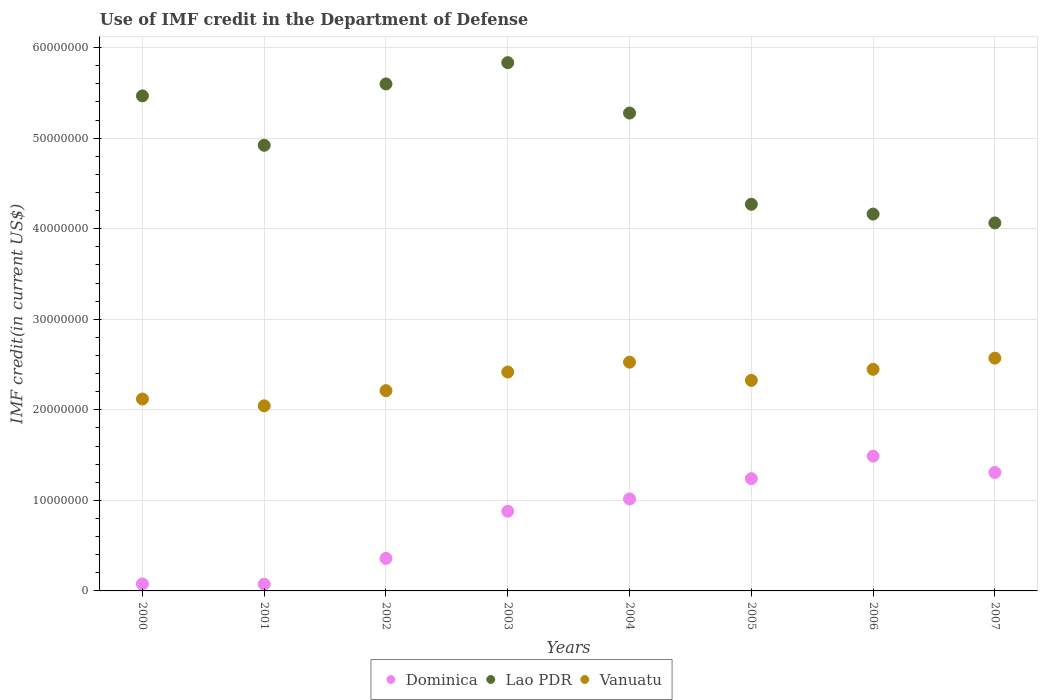What is the IMF credit in the Department of Defense in Lao PDR in 2005?
Ensure brevity in your answer.  4.27e+07. Across all years, what is the maximum IMF credit in the Department of Defense in Dominica?
Offer a very short reply. 1.49e+07. Across all years, what is the minimum IMF credit in the Department of Defense in Lao PDR?
Offer a terse response. 4.06e+07. In which year was the IMF credit in the Department of Defense in Vanuatu maximum?
Your answer should be compact. 2007. In which year was the IMF credit in the Department of Defense in Dominica minimum?
Make the answer very short. 2001. What is the total IMF credit in the Department of Defense in Lao PDR in the graph?
Offer a very short reply. 3.96e+08. What is the difference between the IMF credit in the Department of Defense in Dominica in 2004 and that in 2007?
Offer a very short reply. -2.93e+06. What is the difference between the IMF credit in the Department of Defense in Vanuatu in 2006 and the IMF credit in the Department of Defense in Lao PDR in 2004?
Ensure brevity in your answer.  -2.83e+07. What is the average IMF credit in the Department of Defense in Dominica per year?
Offer a very short reply. 8.05e+06. In the year 2001, what is the difference between the IMF credit in the Department of Defense in Dominica and IMF credit in the Department of Defense in Vanuatu?
Make the answer very short. -1.97e+07. In how many years, is the IMF credit in the Department of Defense in Vanuatu greater than 48000000 US$?
Keep it short and to the point. 0. What is the ratio of the IMF credit in the Department of Defense in Lao PDR in 2005 to that in 2006?
Provide a short and direct response. 1.03. Is the IMF credit in the Department of Defense in Vanuatu in 2003 less than that in 2007?
Provide a short and direct response. Yes. Is the difference between the IMF credit in the Department of Defense in Dominica in 2003 and 2005 greater than the difference between the IMF credit in the Department of Defense in Vanuatu in 2003 and 2005?
Provide a succinct answer. No. What is the difference between the highest and the second highest IMF credit in the Department of Defense in Lao PDR?
Keep it short and to the point. 2.35e+06. What is the difference between the highest and the lowest IMF credit in the Department of Defense in Lao PDR?
Provide a short and direct response. 1.77e+07. In how many years, is the IMF credit in the Department of Defense in Lao PDR greater than the average IMF credit in the Department of Defense in Lao PDR taken over all years?
Provide a short and direct response. 4. Is it the case that in every year, the sum of the IMF credit in the Department of Defense in Dominica and IMF credit in the Department of Defense in Lao PDR  is greater than the IMF credit in the Department of Defense in Vanuatu?
Make the answer very short. Yes. Does the IMF credit in the Department of Defense in Vanuatu monotonically increase over the years?
Offer a terse response. No. Is the IMF credit in the Department of Defense in Dominica strictly greater than the IMF credit in the Department of Defense in Vanuatu over the years?
Ensure brevity in your answer.  No. Is the IMF credit in the Department of Defense in Dominica strictly less than the IMF credit in the Department of Defense in Lao PDR over the years?
Make the answer very short. Yes. How many dotlines are there?
Make the answer very short. 3. How many years are there in the graph?
Your answer should be very brief. 8. What is the difference between two consecutive major ticks on the Y-axis?
Keep it short and to the point. 1.00e+07. Are the values on the major ticks of Y-axis written in scientific E-notation?
Your answer should be very brief. No. Does the graph contain any zero values?
Make the answer very short. No. Does the graph contain grids?
Keep it short and to the point. Yes. How many legend labels are there?
Keep it short and to the point. 3. What is the title of the graph?
Your response must be concise. Use of IMF credit in the Department of Defense. Does "Uganda" appear as one of the legend labels in the graph?
Provide a succinct answer. No. What is the label or title of the X-axis?
Your answer should be very brief. Years. What is the label or title of the Y-axis?
Give a very brief answer. IMF credit(in current US$). What is the IMF credit(in current US$) in Dominica in 2000?
Ensure brevity in your answer.  7.72e+05. What is the IMF credit(in current US$) in Lao PDR in 2000?
Offer a very short reply. 5.47e+07. What is the IMF credit(in current US$) of Vanuatu in 2000?
Your response must be concise. 2.12e+07. What is the IMF credit(in current US$) in Dominica in 2001?
Ensure brevity in your answer.  7.44e+05. What is the IMF credit(in current US$) of Lao PDR in 2001?
Offer a very short reply. 4.92e+07. What is the IMF credit(in current US$) of Vanuatu in 2001?
Give a very brief answer. 2.04e+07. What is the IMF credit(in current US$) in Dominica in 2002?
Make the answer very short. 3.59e+06. What is the IMF credit(in current US$) in Lao PDR in 2002?
Your response must be concise. 5.60e+07. What is the IMF credit(in current US$) of Vanuatu in 2002?
Your response must be concise. 2.21e+07. What is the IMF credit(in current US$) of Dominica in 2003?
Your answer should be compact. 8.80e+06. What is the IMF credit(in current US$) of Lao PDR in 2003?
Make the answer very short. 5.83e+07. What is the IMF credit(in current US$) of Vanuatu in 2003?
Keep it short and to the point. 2.42e+07. What is the IMF credit(in current US$) of Dominica in 2004?
Ensure brevity in your answer.  1.02e+07. What is the IMF credit(in current US$) of Lao PDR in 2004?
Offer a very short reply. 5.28e+07. What is the IMF credit(in current US$) in Vanuatu in 2004?
Give a very brief answer. 2.53e+07. What is the IMF credit(in current US$) in Dominica in 2005?
Your answer should be very brief. 1.24e+07. What is the IMF credit(in current US$) in Lao PDR in 2005?
Offer a very short reply. 4.27e+07. What is the IMF credit(in current US$) of Vanuatu in 2005?
Offer a terse response. 2.32e+07. What is the IMF credit(in current US$) of Dominica in 2006?
Offer a terse response. 1.49e+07. What is the IMF credit(in current US$) in Lao PDR in 2006?
Give a very brief answer. 4.16e+07. What is the IMF credit(in current US$) in Vanuatu in 2006?
Offer a terse response. 2.45e+07. What is the IMF credit(in current US$) in Dominica in 2007?
Your response must be concise. 1.31e+07. What is the IMF credit(in current US$) in Lao PDR in 2007?
Keep it short and to the point. 4.06e+07. What is the IMF credit(in current US$) in Vanuatu in 2007?
Offer a terse response. 2.57e+07. Across all years, what is the maximum IMF credit(in current US$) of Dominica?
Offer a terse response. 1.49e+07. Across all years, what is the maximum IMF credit(in current US$) of Lao PDR?
Your answer should be compact. 5.83e+07. Across all years, what is the maximum IMF credit(in current US$) in Vanuatu?
Your response must be concise. 2.57e+07. Across all years, what is the minimum IMF credit(in current US$) of Dominica?
Provide a short and direct response. 7.44e+05. Across all years, what is the minimum IMF credit(in current US$) in Lao PDR?
Keep it short and to the point. 4.06e+07. Across all years, what is the minimum IMF credit(in current US$) in Vanuatu?
Your answer should be compact. 2.04e+07. What is the total IMF credit(in current US$) in Dominica in the graph?
Your answer should be very brief. 6.44e+07. What is the total IMF credit(in current US$) of Lao PDR in the graph?
Provide a short and direct response. 3.96e+08. What is the total IMF credit(in current US$) of Vanuatu in the graph?
Ensure brevity in your answer.  1.87e+08. What is the difference between the IMF credit(in current US$) of Dominica in 2000 and that in 2001?
Ensure brevity in your answer.  2.80e+04. What is the difference between the IMF credit(in current US$) of Lao PDR in 2000 and that in 2001?
Ensure brevity in your answer.  5.46e+06. What is the difference between the IMF credit(in current US$) of Vanuatu in 2000 and that in 2001?
Offer a terse response. 7.51e+05. What is the difference between the IMF credit(in current US$) in Dominica in 2000 and that in 2002?
Give a very brief answer. -2.82e+06. What is the difference between the IMF credit(in current US$) of Lao PDR in 2000 and that in 2002?
Give a very brief answer. -1.32e+06. What is the difference between the IMF credit(in current US$) of Vanuatu in 2000 and that in 2002?
Your answer should be compact. -9.21e+05. What is the difference between the IMF credit(in current US$) of Dominica in 2000 and that in 2003?
Make the answer very short. -8.03e+06. What is the difference between the IMF credit(in current US$) of Lao PDR in 2000 and that in 2003?
Provide a short and direct response. -3.67e+06. What is the difference between the IMF credit(in current US$) of Vanuatu in 2000 and that in 2003?
Your answer should be very brief. -2.98e+06. What is the difference between the IMF credit(in current US$) in Dominica in 2000 and that in 2004?
Your response must be concise. -9.38e+06. What is the difference between the IMF credit(in current US$) of Lao PDR in 2000 and that in 2004?
Make the answer very short. 1.89e+06. What is the difference between the IMF credit(in current US$) in Vanuatu in 2000 and that in 2004?
Provide a succinct answer. -4.07e+06. What is the difference between the IMF credit(in current US$) in Dominica in 2000 and that in 2005?
Make the answer very short. -1.16e+07. What is the difference between the IMF credit(in current US$) of Lao PDR in 2000 and that in 2005?
Offer a very short reply. 1.20e+07. What is the difference between the IMF credit(in current US$) in Vanuatu in 2000 and that in 2005?
Your answer should be compact. -2.06e+06. What is the difference between the IMF credit(in current US$) of Dominica in 2000 and that in 2006?
Make the answer very short. -1.41e+07. What is the difference between the IMF credit(in current US$) of Lao PDR in 2000 and that in 2006?
Your answer should be compact. 1.31e+07. What is the difference between the IMF credit(in current US$) of Vanuatu in 2000 and that in 2006?
Provide a short and direct response. -3.28e+06. What is the difference between the IMF credit(in current US$) in Dominica in 2000 and that in 2007?
Your answer should be compact. -1.23e+07. What is the difference between the IMF credit(in current US$) in Lao PDR in 2000 and that in 2007?
Make the answer very short. 1.40e+07. What is the difference between the IMF credit(in current US$) in Vanuatu in 2000 and that in 2007?
Your response must be concise. -4.51e+06. What is the difference between the IMF credit(in current US$) of Dominica in 2001 and that in 2002?
Your response must be concise. -2.85e+06. What is the difference between the IMF credit(in current US$) in Lao PDR in 2001 and that in 2002?
Keep it short and to the point. -6.78e+06. What is the difference between the IMF credit(in current US$) in Vanuatu in 2001 and that in 2002?
Your answer should be very brief. -1.67e+06. What is the difference between the IMF credit(in current US$) of Dominica in 2001 and that in 2003?
Keep it short and to the point. -8.06e+06. What is the difference between the IMF credit(in current US$) of Lao PDR in 2001 and that in 2003?
Ensure brevity in your answer.  -9.13e+06. What is the difference between the IMF credit(in current US$) in Vanuatu in 2001 and that in 2003?
Your answer should be compact. -3.73e+06. What is the difference between the IMF credit(in current US$) in Dominica in 2001 and that in 2004?
Your answer should be very brief. -9.41e+06. What is the difference between the IMF credit(in current US$) in Lao PDR in 2001 and that in 2004?
Offer a very short reply. -3.56e+06. What is the difference between the IMF credit(in current US$) of Vanuatu in 2001 and that in 2004?
Your answer should be compact. -4.82e+06. What is the difference between the IMF credit(in current US$) of Dominica in 2001 and that in 2005?
Keep it short and to the point. -1.17e+07. What is the difference between the IMF credit(in current US$) of Lao PDR in 2001 and that in 2005?
Provide a short and direct response. 6.51e+06. What is the difference between the IMF credit(in current US$) in Vanuatu in 2001 and that in 2005?
Offer a terse response. -2.81e+06. What is the difference between the IMF credit(in current US$) of Dominica in 2001 and that in 2006?
Provide a succinct answer. -1.41e+07. What is the difference between the IMF credit(in current US$) of Lao PDR in 2001 and that in 2006?
Ensure brevity in your answer.  7.60e+06. What is the difference between the IMF credit(in current US$) of Vanuatu in 2001 and that in 2006?
Ensure brevity in your answer.  -4.03e+06. What is the difference between the IMF credit(in current US$) of Dominica in 2001 and that in 2007?
Give a very brief answer. -1.23e+07. What is the difference between the IMF credit(in current US$) in Lao PDR in 2001 and that in 2007?
Keep it short and to the point. 8.57e+06. What is the difference between the IMF credit(in current US$) of Vanuatu in 2001 and that in 2007?
Your answer should be very brief. -5.26e+06. What is the difference between the IMF credit(in current US$) in Dominica in 2002 and that in 2003?
Provide a succinct answer. -5.21e+06. What is the difference between the IMF credit(in current US$) in Lao PDR in 2002 and that in 2003?
Provide a short and direct response. -2.35e+06. What is the difference between the IMF credit(in current US$) of Vanuatu in 2002 and that in 2003?
Your answer should be compact. -2.06e+06. What is the difference between the IMF credit(in current US$) of Dominica in 2002 and that in 2004?
Give a very brief answer. -6.56e+06. What is the difference between the IMF credit(in current US$) of Lao PDR in 2002 and that in 2004?
Provide a short and direct response. 3.21e+06. What is the difference between the IMF credit(in current US$) of Vanuatu in 2002 and that in 2004?
Keep it short and to the point. -3.15e+06. What is the difference between the IMF credit(in current US$) of Dominica in 2002 and that in 2005?
Provide a succinct answer. -8.81e+06. What is the difference between the IMF credit(in current US$) of Lao PDR in 2002 and that in 2005?
Provide a short and direct response. 1.33e+07. What is the difference between the IMF credit(in current US$) in Vanuatu in 2002 and that in 2005?
Your answer should be very brief. -1.14e+06. What is the difference between the IMF credit(in current US$) of Dominica in 2002 and that in 2006?
Make the answer very short. -1.13e+07. What is the difference between the IMF credit(in current US$) in Lao PDR in 2002 and that in 2006?
Your answer should be very brief. 1.44e+07. What is the difference between the IMF credit(in current US$) of Vanuatu in 2002 and that in 2006?
Your answer should be compact. -2.36e+06. What is the difference between the IMF credit(in current US$) of Dominica in 2002 and that in 2007?
Offer a very short reply. -9.49e+06. What is the difference between the IMF credit(in current US$) of Lao PDR in 2002 and that in 2007?
Your answer should be very brief. 1.53e+07. What is the difference between the IMF credit(in current US$) of Vanuatu in 2002 and that in 2007?
Keep it short and to the point. -3.59e+06. What is the difference between the IMF credit(in current US$) in Dominica in 2003 and that in 2004?
Ensure brevity in your answer.  -1.35e+06. What is the difference between the IMF credit(in current US$) of Lao PDR in 2003 and that in 2004?
Your answer should be very brief. 5.56e+06. What is the difference between the IMF credit(in current US$) of Vanuatu in 2003 and that in 2004?
Make the answer very short. -1.09e+06. What is the difference between the IMF credit(in current US$) in Dominica in 2003 and that in 2005?
Keep it short and to the point. -3.60e+06. What is the difference between the IMF credit(in current US$) in Lao PDR in 2003 and that in 2005?
Your response must be concise. 1.56e+07. What is the difference between the IMF credit(in current US$) in Vanuatu in 2003 and that in 2005?
Give a very brief answer. 9.22e+05. What is the difference between the IMF credit(in current US$) in Dominica in 2003 and that in 2006?
Provide a succinct answer. -6.08e+06. What is the difference between the IMF credit(in current US$) in Lao PDR in 2003 and that in 2006?
Provide a short and direct response. 1.67e+07. What is the difference between the IMF credit(in current US$) of Vanuatu in 2003 and that in 2006?
Your answer should be very brief. -3.00e+05. What is the difference between the IMF credit(in current US$) in Dominica in 2003 and that in 2007?
Ensure brevity in your answer.  -4.28e+06. What is the difference between the IMF credit(in current US$) in Lao PDR in 2003 and that in 2007?
Keep it short and to the point. 1.77e+07. What is the difference between the IMF credit(in current US$) in Vanuatu in 2003 and that in 2007?
Provide a short and direct response. -1.53e+06. What is the difference between the IMF credit(in current US$) in Dominica in 2004 and that in 2005?
Your answer should be compact. -2.24e+06. What is the difference between the IMF credit(in current US$) in Lao PDR in 2004 and that in 2005?
Provide a succinct answer. 1.01e+07. What is the difference between the IMF credit(in current US$) of Vanuatu in 2004 and that in 2005?
Ensure brevity in your answer.  2.01e+06. What is the difference between the IMF credit(in current US$) of Dominica in 2004 and that in 2006?
Provide a short and direct response. -4.73e+06. What is the difference between the IMF credit(in current US$) of Lao PDR in 2004 and that in 2006?
Ensure brevity in your answer.  1.12e+07. What is the difference between the IMF credit(in current US$) of Vanuatu in 2004 and that in 2006?
Ensure brevity in your answer.  7.90e+05. What is the difference between the IMF credit(in current US$) in Dominica in 2004 and that in 2007?
Provide a succinct answer. -2.93e+06. What is the difference between the IMF credit(in current US$) in Lao PDR in 2004 and that in 2007?
Your response must be concise. 1.21e+07. What is the difference between the IMF credit(in current US$) of Vanuatu in 2004 and that in 2007?
Ensure brevity in your answer.  -4.44e+05. What is the difference between the IMF credit(in current US$) in Dominica in 2005 and that in 2006?
Make the answer very short. -2.49e+06. What is the difference between the IMF credit(in current US$) of Lao PDR in 2005 and that in 2006?
Provide a short and direct response. 1.08e+06. What is the difference between the IMF credit(in current US$) of Vanuatu in 2005 and that in 2006?
Ensure brevity in your answer.  -1.22e+06. What is the difference between the IMF credit(in current US$) of Dominica in 2005 and that in 2007?
Your response must be concise. -6.87e+05. What is the difference between the IMF credit(in current US$) of Lao PDR in 2005 and that in 2007?
Provide a short and direct response. 2.06e+06. What is the difference between the IMF credit(in current US$) in Vanuatu in 2005 and that in 2007?
Make the answer very short. -2.46e+06. What is the difference between the IMF credit(in current US$) in Dominica in 2006 and that in 2007?
Offer a terse response. 1.80e+06. What is the difference between the IMF credit(in current US$) of Lao PDR in 2006 and that in 2007?
Provide a short and direct response. 9.76e+05. What is the difference between the IMF credit(in current US$) of Vanuatu in 2006 and that in 2007?
Keep it short and to the point. -1.23e+06. What is the difference between the IMF credit(in current US$) of Dominica in 2000 and the IMF credit(in current US$) of Lao PDR in 2001?
Your answer should be very brief. -4.84e+07. What is the difference between the IMF credit(in current US$) in Dominica in 2000 and the IMF credit(in current US$) in Vanuatu in 2001?
Your response must be concise. -1.97e+07. What is the difference between the IMF credit(in current US$) in Lao PDR in 2000 and the IMF credit(in current US$) in Vanuatu in 2001?
Provide a short and direct response. 3.42e+07. What is the difference between the IMF credit(in current US$) in Dominica in 2000 and the IMF credit(in current US$) in Lao PDR in 2002?
Offer a very short reply. -5.52e+07. What is the difference between the IMF credit(in current US$) in Dominica in 2000 and the IMF credit(in current US$) in Vanuatu in 2002?
Ensure brevity in your answer.  -2.13e+07. What is the difference between the IMF credit(in current US$) in Lao PDR in 2000 and the IMF credit(in current US$) in Vanuatu in 2002?
Keep it short and to the point. 3.26e+07. What is the difference between the IMF credit(in current US$) of Dominica in 2000 and the IMF credit(in current US$) of Lao PDR in 2003?
Offer a very short reply. -5.76e+07. What is the difference between the IMF credit(in current US$) of Dominica in 2000 and the IMF credit(in current US$) of Vanuatu in 2003?
Ensure brevity in your answer.  -2.34e+07. What is the difference between the IMF credit(in current US$) in Lao PDR in 2000 and the IMF credit(in current US$) in Vanuatu in 2003?
Keep it short and to the point. 3.05e+07. What is the difference between the IMF credit(in current US$) of Dominica in 2000 and the IMF credit(in current US$) of Lao PDR in 2004?
Give a very brief answer. -5.20e+07. What is the difference between the IMF credit(in current US$) in Dominica in 2000 and the IMF credit(in current US$) in Vanuatu in 2004?
Your answer should be compact. -2.45e+07. What is the difference between the IMF credit(in current US$) of Lao PDR in 2000 and the IMF credit(in current US$) of Vanuatu in 2004?
Offer a terse response. 2.94e+07. What is the difference between the IMF credit(in current US$) of Dominica in 2000 and the IMF credit(in current US$) of Lao PDR in 2005?
Ensure brevity in your answer.  -4.19e+07. What is the difference between the IMF credit(in current US$) in Dominica in 2000 and the IMF credit(in current US$) in Vanuatu in 2005?
Your answer should be compact. -2.25e+07. What is the difference between the IMF credit(in current US$) of Lao PDR in 2000 and the IMF credit(in current US$) of Vanuatu in 2005?
Provide a short and direct response. 3.14e+07. What is the difference between the IMF credit(in current US$) of Dominica in 2000 and the IMF credit(in current US$) of Lao PDR in 2006?
Your answer should be compact. -4.08e+07. What is the difference between the IMF credit(in current US$) of Dominica in 2000 and the IMF credit(in current US$) of Vanuatu in 2006?
Offer a terse response. -2.37e+07. What is the difference between the IMF credit(in current US$) of Lao PDR in 2000 and the IMF credit(in current US$) of Vanuatu in 2006?
Provide a succinct answer. 3.02e+07. What is the difference between the IMF credit(in current US$) of Dominica in 2000 and the IMF credit(in current US$) of Lao PDR in 2007?
Your response must be concise. -3.99e+07. What is the difference between the IMF credit(in current US$) of Dominica in 2000 and the IMF credit(in current US$) of Vanuatu in 2007?
Provide a succinct answer. -2.49e+07. What is the difference between the IMF credit(in current US$) of Lao PDR in 2000 and the IMF credit(in current US$) of Vanuatu in 2007?
Your answer should be compact. 2.90e+07. What is the difference between the IMF credit(in current US$) of Dominica in 2001 and the IMF credit(in current US$) of Lao PDR in 2002?
Ensure brevity in your answer.  -5.52e+07. What is the difference between the IMF credit(in current US$) in Dominica in 2001 and the IMF credit(in current US$) in Vanuatu in 2002?
Give a very brief answer. -2.14e+07. What is the difference between the IMF credit(in current US$) of Lao PDR in 2001 and the IMF credit(in current US$) of Vanuatu in 2002?
Make the answer very short. 2.71e+07. What is the difference between the IMF credit(in current US$) of Dominica in 2001 and the IMF credit(in current US$) of Lao PDR in 2003?
Your answer should be compact. -5.76e+07. What is the difference between the IMF credit(in current US$) in Dominica in 2001 and the IMF credit(in current US$) in Vanuatu in 2003?
Your answer should be compact. -2.34e+07. What is the difference between the IMF credit(in current US$) in Lao PDR in 2001 and the IMF credit(in current US$) in Vanuatu in 2003?
Offer a terse response. 2.50e+07. What is the difference between the IMF credit(in current US$) of Dominica in 2001 and the IMF credit(in current US$) of Lao PDR in 2004?
Keep it short and to the point. -5.20e+07. What is the difference between the IMF credit(in current US$) of Dominica in 2001 and the IMF credit(in current US$) of Vanuatu in 2004?
Your answer should be compact. -2.45e+07. What is the difference between the IMF credit(in current US$) in Lao PDR in 2001 and the IMF credit(in current US$) in Vanuatu in 2004?
Provide a succinct answer. 2.39e+07. What is the difference between the IMF credit(in current US$) of Dominica in 2001 and the IMF credit(in current US$) of Lao PDR in 2005?
Ensure brevity in your answer.  -4.20e+07. What is the difference between the IMF credit(in current US$) of Dominica in 2001 and the IMF credit(in current US$) of Vanuatu in 2005?
Give a very brief answer. -2.25e+07. What is the difference between the IMF credit(in current US$) in Lao PDR in 2001 and the IMF credit(in current US$) in Vanuatu in 2005?
Give a very brief answer. 2.60e+07. What is the difference between the IMF credit(in current US$) of Dominica in 2001 and the IMF credit(in current US$) of Lao PDR in 2006?
Ensure brevity in your answer.  -4.09e+07. What is the difference between the IMF credit(in current US$) in Dominica in 2001 and the IMF credit(in current US$) in Vanuatu in 2006?
Make the answer very short. -2.37e+07. What is the difference between the IMF credit(in current US$) in Lao PDR in 2001 and the IMF credit(in current US$) in Vanuatu in 2006?
Provide a short and direct response. 2.47e+07. What is the difference between the IMF credit(in current US$) of Dominica in 2001 and the IMF credit(in current US$) of Lao PDR in 2007?
Give a very brief answer. -3.99e+07. What is the difference between the IMF credit(in current US$) in Dominica in 2001 and the IMF credit(in current US$) in Vanuatu in 2007?
Your answer should be compact. -2.50e+07. What is the difference between the IMF credit(in current US$) in Lao PDR in 2001 and the IMF credit(in current US$) in Vanuatu in 2007?
Make the answer very short. 2.35e+07. What is the difference between the IMF credit(in current US$) in Dominica in 2002 and the IMF credit(in current US$) in Lao PDR in 2003?
Offer a very short reply. -5.47e+07. What is the difference between the IMF credit(in current US$) in Dominica in 2002 and the IMF credit(in current US$) in Vanuatu in 2003?
Give a very brief answer. -2.06e+07. What is the difference between the IMF credit(in current US$) in Lao PDR in 2002 and the IMF credit(in current US$) in Vanuatu in 2003?
Give a very brief answer. 3.18e+07. What is the difference between the IMF credit(in current US$) in Dominica in 2002 and the IMF credit(in current US$) in Lao PDR in 2004?
Ensure brevity in your answer.  -4.92e+07. What is the difference between the IMF credit(in current US$) in Dominica in 2002 and the IMF credit(in current US$) in Vanuatu in 2004?
Keep it short and to the point. -2.17e+07. What is the difference between the IMF credit(in current US$) in Lao PDR in 2002 and the IMF credit(in current US$) in Vanuatu in 2004?
Your answer should be compact. 3.07e+07. What is the difference between the IMF credit(in current US$) in Dominica in 2002 and the IMF credit(in current US$) in Lao PDR in 2005?
Make the answer very short. -3.91e+07. What is the difference between the IMF credit(in current US$) of Dominica in 2002 and the IMF credit(in current US$) of Vanuatu in 2005?
Offer a terse response. -1.97e+07. What is the difference between the IMF credit(in current US$) of Lao PDR in 2002 and the IMF credit(in current US$) of Vanuatu in 2005?
Make the answer very short. 3.27e+07. What is the difference between the IMF credit(in current US$) in Dominica in 2002 and the IMF credit(in current US$) in Lao PDR in 2006?
Make the answer very short. -3.80e+07. What is the difference between the IMF credit(in current US$) in Dominica in 2002 and the IMF credit(in current US$) in Vanuatu in 2006?
Offer a very short reply. -2.09e+07. What is the difference between the IMF credit(in current US$) in Lao PDR in 2002 and the IMF credit(in current US$) in Vanuatu in 2006?
Your response must be concise. 3.15e+07. What is the difference between the IMF credit(in current US$) of Dominica in 2002 and the IMF credit(in current US$) of Lao PDR in 2007?
Your answer should be compact. -3.70e+07. What is the difference between the IMF credit(in current US$) in Dominica in 2002 and the IMF credit(in current US$) in Vanuatu in 2007?
Provide a succinct answer. -2.21e+07. What is the difference between the IMF credit(in current US$) in Lao PDR in 2002 and the IMF credit(in current US$) in Vanuatu in 2007?
Provide a succinct answer. 3.03e+07. What is the difference between the IMF credit(in current US$) of Dominica in 2003 and the IMF credit(in current US$) of Lao PDR in 2004?
Your response must be concise. -4.40e+07. What is the difference between the IMF credit(in current US$) in Dominica in 2003 and the IMF credit(in current US$) in Vanuatu in 2004?
Offer a very short reply. -1.65e+07. What is the difference between the IMF credit(in current US$) in Lao PDR in 2003 and the IMF credit(in current US$) in Vanuatu in 2004?
Your response must be concise. 3.31e+07. What is the difference between the IMF credit(in current US$) in Dominica in 2003 and the IMF credit(in current US$) in Lao PDR in 2005?
Give a very brief answer. -3.39e+07. What is the difference between the IMF credit(in current US$) of Dominica in 2003 and the IMF credit(in current US$) of Vanuatu in 2005?
Give a very brief answer. -1.44e+07. What is the difference between the IMF credit(in current US$) in Lao PDR in 2003 and the IMF credit(in current US$) in Vanuatu in 2005?
Ensure brevity in your answer.  3.51e+07. What is the difference between the IMF credit(in current US$) in Dominica in 2003 and the IMF credit(in current US$) in Lao PDR in 2006?
Ensure brevity in your answer.  -3.28e+07. What is the difference between the IMF credit(in current US$) of Dominica in 2003 and the IMF credit(in current US$) of Vanuatu in 2006?
Offer a very short reply. -1.57e+07. What is the difference between the IMF credit(in current US$) in Lao PDR in 2003 and the IMF credit(in current US$) in Vanuatu in 2006?
Make the answer very short. 3.39e+07. What is the difference between the IMF credit(in current US$) in Dominica in 2003 and the IMF credit(in current US$) in Lao PDR in 2007?
Provide a succinct answer. -3.18e+07. What is the difference between the IMF credit(in current US$) in Dominica in 2003 and the IMF credit(in current US$) in Vanuatu in 2007?
Ensure brevity in your answer.  -1.69e+07. What is the difference between the IMF credit(in current US$) in Lao PDR in 2003 and the IMF credit(in current US$) in Vanuatu in 2007?
Provide a short and direct response. 3.26e+07. What is the difference between the IMF credit(in current US$) of Dominica in 2004 and the IMF credit(in current US$) of Lao PDR in 2005?
Offer a terse response. -3.25e+07. What is the difference between the IMF credit(in current US$) of Dominica in 2004 and the IMF credit(in current US$) of Vanuatu in 2005?
Offer a very short reply. -1.31e+07. What is the difference between the IMF credit(in current US$) in Lao PDR in 2004 and the IMF credit(in current US$) in Vanuatu in 2005?
Your response must be concise. 2.95e+07. What is the difference between the IMF credit(in current US$) in Dominica in 2004 and the IMF credit(in current US$) in Lao PDR in 2006?
Offer a very short reply. -3.15e+07. What is the difference between the IMF credit(in current US$) of Dominica in 2004 and the IMF credit(in current US$) of Vanuatu in 2006?
Your answer should be very brief. -1.43e+07. What is the difference between the IMF credit(in current US$) of Lao PDR in 2004 and the IMF credit(in current US$) of Vanuatu in 2006?
Keep it short and to the point. 2.83e+07. What is the difference between the IMF credit(in current US$) of Dominica in 2004 and the IMF credit(in current US$) of Lao PDR in 2007?
Keep it short and to the point. -3.05e+07. What is the difference between the IMF credit(in current US$) in Dominica in 2004 and the IMF credit(in current US$) in Vanuatu in 2007?
Make the answer very short. -1.56e+07. What is the difference between the IMF credit(in current US$) in Lao PDR in 2004 and the IMF credit(in current US$) in Vanuatu in 2007?
Offer a very short reply. 2.71e+07. What is the difference between the IMF credit(in current US$) of Dominica in 2005 and the IMF credit(in current US$) of Lao PDR in 2006?
Keep it short and to the point. -2.92e+07. What is the difference between the IMF credit(in current US$) of Dominica in 2005 and the IMF credit(in current US$) of Vanuatu in 2006?
Ensure brevity in your answer.  -1.21e+07. What is the difference between the IMF credit(in current US$) in Lao PDR in 2005 and the IMF credit(in current US$) in Vanuatu in 2006?
Ensure brevity in your answer.  1.82e+07. What is the difference between the IMF credit(in current US$) of Dominica in 2005 and the IMF credit(in current US$) of Lao PDR in 2007?
Your response must be concise. -2.82e+07. What is the difference between the IMF credit(in current US$) of Dominica in 2005 and the IMF credit(in current US$) of Vanuatu in 2007?
Make the answer very short. -1.33e+07. What is the difference between the IMF credit(in current US$) of Lao PDR in 2005 and the IMF credit(in current US$) of Vanuatu in 2007?
Ensure brevity in your answer.  1.70e+07. What is the difference between the IMF credit(in current US$) in Dominica in 2006 and the IMF credit(in current US$) in Lao PDR in 2007?
Make the answer very short. -2.58e+07. What is the difference between the IMF credit(in current US$) of Dominica in 2006 and the IMF credit(in current US$) of Vanuatu in 2007?
Your response must be concise. -1.08e+07. What is the difference between the IMF credit(in current US$) of Lao PDR in 2006 and the IMF credit(in current US$) of Vanuatu in 2007?
Provide a short and direct response. 1.59e+07. What is the average IMF credit(in current US$) in Dominica per year?
Your response must be concise. 8.05e+06. What is the average IMF credit(in current US$) of Lao PDR per year?
Keep it short and to the point. 4.95e+07. What is the average IMF credit(in current US$) in Vanuatu per year?
Provide a short and direct response. 2.33e+07. In the year 2000, what is the difference between the IMF credit(in current US$) of Dominica and IMF credit(in current US$) of Lao PDR?
Give a very brief answer. -5.39e+07. In the year 2000, what is the difference between the IMF credit(in current US$) of Dominica and IMF credit(in current US$) of Vanuatu?
Your answer should be very brief. -2.04e+07. In the year 2000, what is the difference between the IMF credit(in current US$) of Lao PDR and IMF credit(in current US$) of Vanuatu?
Provide a succinct answer. 3.35e+07. In the year 2001, what is the difference between the IMF credit(in current US$) of Dominica and IMF credit(in current US$) of Lao PDR?
Your answer should be compact. -4.85e+07. In the year 2001, what is the difference between the IMF credit(in current US$) in Dominica and IMF credit(in current US$) in Vanuatu?
Provide a succinct answer. -1.97e+07. In the year 2001, what is the difference between the IMF credit(in current US$) in Lao PDR and IMF credit(in current US$) in Vanuatu?
Offer a very short reply. 2.88e+07. In the year 2002, what is the difference between the IMF credit(in current US$) of Dominica and IMF credit(in current US$) of Lao PDR?
Offer a terse response. -5.24e+07. In the year 2002, what is the difference between the IMF credit(in current US$) of Dominica and IMF credit(in current US$) of Vanuatu?
Keep it short and to the point. -1.85e+07. In the year 2002, what is the difference between the IMF credit(in current US$) of Lao PDR and IMF credit(in current US$) of Vanuatu?
Provide a succinct answer. 3.39e+07. In the year 2003, what is the difference between the IMF credit(in current US$) of Dominica and IMF credit(in current US$) of Lao PDR?
Keep it short and to the point. -4.95e+07. In the year 2003, what is the difference between the IMF credit(in current US$) in Dominica and IMF credit(in current US$) in Vanuatu?
Your answer should be compact. -1.54e+07. In the year 2003, what is the difference between the IMF credit(in current US$) of Lao PDR and IMF credit(in current US$) of Vanuatu?
Ensure brevity in your answer.  3.42e+07. In the year 2004, what is the difference between the IMF credit(in current US$) in Dominica and IMF credit(in current US$) in Lao PDR?
Give a very brief answer. -4.26e+07. In the year 2004, what is the difference between the IMF credit(in current US$) in Dominica and IMF credit(in current US$) in Vanuatu?
Give a very brief answer. -1.51e+07. In the year 2004, what is the difference between the IMF credit(in current US$) in Lao PDR and IMF credit(in current US$) in Vanuatu?
Ensure brevity in your answer.  2.75e+07. In the year 2005, what is the difference between the IMF credit(in current US$) in Dominica and IMF credit(in current US$) in Lao PDR?
Your answer should be compact. -3.03e+07. In the year 2005, what is the difference between the IMF credit(in current US$) in Dominica and IMF credit(in current US$) in Vanuatu?
Provide a short and direct response. -1.09e+07. In the year 2005, what is the difference between the IMF credit(in current US$) of Lao PDR and IMF credit(in current US$) of Vanuatu?
Give a very brief answer. 1.94e+07. In the year 2006, what is the difference between the IMF credit(in current US$) in Dominica and IMF credit(in current US$) in Lao PDR?
Ensure brevity in your answer.  -2.67e+07. In the year 2006, what is the difference between the IMF credit(in current US$) of Dominica and IMF credit(in current US$) of Vanuatu?
Your answer should be compact. -9.59e+06. In the year 2006, what is the difference between the IMF credit(in current US$) in Lao PDR and IMF credit(in current US$) in Vanuatu?
Your response must be concise. 1.71e+07. In the year 2007, what is the difference between the IMF credit(in current US$) of Dominica and IMF credit(in current US$) of Lao PDR?
Offer a terse response. -2.76e+07. In the year 2007, what is the difference between the IMF credit(in current US$) in Dominica and IMF credit(in current US$) in Vanuatu?
Your response must be concise. -1.26e+07. In the year 2007, what is the difference between the IMF credit(in current US$) in Lao PDR and IMF credit(in current US$) in Vanuatu?
Offer a very short reply. 1.49e+07. What is the ratio of the IMF credit(in current US$) of Dominica in 2000 to that in 2001?
Ensure brevity in your answer.  1.04. What is the ratio of the IMF credit(in current US$) in Lao PDR in 2000 to that in 2001?
Offer a terse response. 1.11. What is the ratio of the IMF credit(in current US$) in Vanuatu in 2000 to that in 2001?
Your answer should be compact. 1.04. What is the ratio of the IMF credit(in current US$) of Dominica in 2000 to that in 2002?
Provide a succinct answer. 0.21. What is the ratio of the IMF credit(in current US$) in Lao PDR in 2000 to that in 2002?
Ensure brevity in your answer.  0.98. What is the ratio of the IMF credit(in current US$) in Vanuatu in 2000 to that in 2002?
Ensure brevity in your answer.  0.96. What is the ratio of the IMF credit(in current US$) in Dominica in 2000 to that in 2003?
Provide a short and direct response. 0.09. What is the ratio of the IMF credit(in current US$) in Lao PDR in 2000 to that in 2003?
Offer a very short reply. 0.94. What is the ratio of the IMF credit(in current US$) of Vanuatu in 2000 to that in 2003?
Your answer should be very brief. 0.88. What is the ratio of the IMF credit(in current US$) in Dominica in 2000 to that in 2004?
Provide a short and direct response. 0.08. What is the ratio of the IMF credit(in current US$) in Lao PDR in 2000 to that in 2004?
Your response must be concise. 1.04. What is the ratio of the IMF credit(in current US$) of Vanuatu in 2000 to that in 2004?
Offer a terse response. 0.84. What is the ratio of the IMF credit(in current US$) in Dominica in 2000 to that in 2005?
Your answer should be very brief. 0.06. What is the ratio of the IMF credit(in current US$) in Lao PDR in 2000 to that in 2005?
Offer a very short reply. 1.28. What is the ratio of the IMF credit(in current US$) of Vanuatu in 2000 to that in 2005?
Provide a succinct answer. 0.91. What is the ratio of the IMF credit(in current US$) in Dominica in 2000 to that in 2006?
Your response must be concise. 0.05. What is the ratio of the IMF credit(in current US$) in Lao PDR in 2000 to that in 2006?
Your response must be concise. 1.31. What is the ratio of the IMF credit(in current US$) of Vanuatu in 2000 to that in 2006?
Offer a terse response. 0.87. What is the ratio of the IMF credit(in current US$) of Dominica in 2000 to that in 2007?
Give a very brief answer. 0.06. What is the ratio of the IMF credit(in current US$) of Lao PDR in 2000 to that in 2007?
Make the answer very short. 1.35. What is the ratio of the IMF credit(in current US$) of Vanuatu in 2000 to that in 2007?
Offer a very short reply. 0.82. What is the ratio of the IMF credit(in current US$) in Dominica in 2001 to that in 2002?
Your answer should be compact. 0.21. What is the ratio of the IMF credit(in current US$) in Lao PDR in 2001 to that in 2002?
Offer a terse response. 0.88. What is the ratio of the IMF credit(in current US$) of Vanuatu in 2001 to that in 2002?
Your answer should be compact. 0.92. What is the ratio of the IMF credit(in current US$) in Dominica in 2001 to that in 2003?
Offer a very short reply. 0.08. What is the ratio of the IMF credit(in current US$) in Lao PDR in 2001 to that in 2003?
Provide a short and direct response. 0.84. What is the ratio of the IMF credit(in current US$) in Vanuatu in 2001 to that in 2003?
Offer a very short reply. 0.85. What is the ratio of the IMF credit(in current US$) of Dominica in 2001 to that in 2004?
Your answer should be compact. 0.07. What is the ratio of the IMF credit(in current US$) of Lao PDR in 2001 to that in 2004?
Make the answer very short. 0.93. What is the ratio of the IMF credit(in current US$) in Vanuatu in 2001 to that in 2004?
Offer a terse response. 0.81. What is the ratio of the IMF credit(in current US$) in Lao PDR in 2001 to that in 2005?
Your answer should be very brief. 1.15. What is the ratio of the IMF credit(in current US$) of Vanuatu in 2001 to that in 2005?
Provide a succinct answer. 0.88. What is the ratio of the IMF credit(in current US$) of Dominica in 2001 to that in 2006?
Your answer should be very brief. 0.05. What is the ratio of the IMF credit(in current US$) in Lao PDR in 2001 to that in 2006?
Keep it short and to the point. 1.18. What is the ratio of the IMF credit(in current US$) in Vanuatu in 2001 to that in 2006?
Your response must be concise. 0.84. What is the ratio of the IMF credit(in current US$) of Dominica in 2001 to that in 2007?
Offer a very short reply. 0.06. What is the ratio of the IMF credit(in current US$) of Lao PDR in 2001 to that in 2007?
Offer a terse response. 1.21. What is the ratio of the IMF credit(in current US$) in Vanuatu in 2001 to that in 2007?
Provide a short and direct response. 0.8. What is the ratio of the IMF credit(in current US$) of Dominica in 2002 to that in 2003?
Offer a very short reply. 0.41. What is the ratio of the IMF credit(in current US$) of Lao PDR in 2002 to that in 2003?
Provide a short and direct response. 0.96. What is the ratio of the IMF credit(in current US$) of Vanuatu in 2002 to that in 2003?
Offer a terse response. 0.91. What is the ratio of the IMF credit(in current US$) in Dominica in 2002 to that in 2004?
Make the answer very short. 0.35. What is the ratio of the IMF credit(in current US$) in Lao PDR in 2002 to that in 2004?
Offer a terse response. 1.06. What is the ratio of the IMF credit(in current US$) in Vanuatu in 2002 to that in 2004?
Make the answer very short. 0.88. What is the ratio of the IMF credit(in current US$) in Dominica in 2002 to that in 2005?
Provide a succinct answer. 0.29. What is the ratio of the IMF credit(in current US$) in Lao PDR in 2002 to that in 2005?
Your answer should be very brief. 1.31. What is the ratio of the IMF credit(in current US$) of Vanuatu in 2002 to that in 2005?
Provide a short and direct response. 0.95. What is the ratio of the IMF credit(in current US$) in Dominica in 2002 to that in 2006?
Make the answer very short. 0.24. What is the ratio of the IMF credit(in current US$) in Lao PDR in 2002 to that in 2006?
Offer a very short reply. 1.35. What is the ratio of the IMF credit(in current US$) of Vanuatu in 2002 to that in 2006?
Make the answer very short. 0.9. What is the ratio of the IMF credit(in current US$) of Dominica in 2002 to that in 2007?
Keep it short and to the point. 0.27. What is the ratio of the IMF credit(in current US$) of Lao PDR in 2002 to that in 2007?
Provide a succinct answer. 1.38. What is the ratio of the IMF credit(in current US$) of Vanuatu in 2002 to that in 2007?
Provide a short and direct response. 0.86. What is the ratio of the IMF credit(in current US$) of Dominica in 2003 to that in 2004?
Your response must be concise. 0.87. What is the ratio of the IMF credit(in current US$) of Lao PDR in 2003 to that in 2004?
Offer a terse response. 1.11. What is the ratio of the IMF credit(in current US$) of Vanuatu in 2003 to that in 2004?
Make the answer very short. 0.96. What is the ratio of the IMF credit(in current US$) in Dominica in 2003 to that in 2005?
Make the answer very short. 0.71. What is the ratio of the IMF credit(in current US$) of Lao PDR in 2003 to that in 2005?
Provide a succinct answer. 1.37. What is the ratio of the IMF credit(in current US$) in Vanuatu in 2003 to that in 2005?
Provide a succinct answer. 1.04. What is the ratio of the IMF credit(in current US$) of Dominica in 2003 to that in 2006?
Your response must be concise. 0.59. What is the ratio of the IMF credit(in current US$) of Lao PDR in 2003 to that in 2006?
Provide a short and direct response. 1.4. What is the ratio of the IMF credit(in current US$) in Dominica in 2003 to that in 2007?
Provide a succinct answer. 0.67. What is the ratio of the IMF credit(in current US$) in Lao PDR in 2003 to that in 2007?
Offer a terse response. 1.44. What is the ratio of the IMF credit(in current US$) in Vanuatu in 2003 to that in 2007?
Offer a terse response. 0.94. What is the ratio of the IMF credit(in current US$) in Dominica in 2004 to that in 2005?
Keep it short and to the point. 0.82. What is the ratio of the IMF credit(in current US$) in Lao PDR in 2004 to that in 2005?
Your answer should be very brief. 1.24. What is the ratio of the IMF credit(in current US$) of Vanuatu in 2004 to that in 2005?
Ensure brevity in your answer.  1.09. What is the ratio of the IMF credit(in current US$) in Dominica in 2004 to that in 2006?
Your answer should be compact. 0.68. What is the ratio of the IMF credit(in current US$) of Lao PDR in 2004 to that in 2006?
Ensure brevity in your answer.  1.27. What is the ratio of the IMF credit(in current US$) of Vanuatu in 2004 to that in 2006?
Offer a very short reply. 1.03. What is the ratio of the IMF credit(in current US$) of Dominica in 2004 to that in 2007?
Give a very brief answer. 0.78. What is the ratio of the IMF credit(in current US$) of Lao PDR in 2004 to that in 2007?
Provide a succinct answer. 1.3. What is the ratio of the IMF credit(in current US$) in Vanuatu in 2004 to that in 2007?
Offer a terse response. 0.98. What is the ratio of the IMF credit(in current US$) of Dominica in 2005 to that in 2006?
Your answer should be very brief. 0.83. What is the ratio of the IMF credit(in current US$) of Lao PDR in 2005 to that in 2006?
Offer a very short reply. 1.03. What is the ratio of the IMF credit(in current US$) of Vanuatu in 2005 to that in 2006?
Offer a terse response. 0.95. What is the ratio of the IMF credit(in current US$) of Dominica in 2005 to that in 2007?
Offer a very short reply. 0.95. What is the ratio of the IMF credit(in current US$) in Lao PDR in 2005 to that in 2007?
Keep it short and to the point. 1.05. What is the ratio of the IMF credit(in current US$) of Vanuatu in 2005 to that in 2007?
Offer a very short reply. 0.9. What is the ratio of the IMF credit(in current US$) of Dominica in 2006 to that in 2007?
Make the answer very short. 1.14. What is the ratio of the IMF credit(in current US$) of Lao PDR in 2006 to that in 2007?
Provide a succinct answer. 1.02. What is the difference between the highest and the second highest IMF credit(in current US$) of Dominica?
Your answer should be very brief. 1.80e+06. What is the difference between the highest and the second highest IMF credit(in current US$) of Lao PDR?
Provide a short and direct response. 2.35e+06. What is the difference between the highest and the second highest IMF credit(in current US$) in Vanuatu?
Keep it short and to the point. 4.44e+05. What is the difference between the highest and the lowest IMF credit(in current US$) in Dominica?
Make the answer very short. 1.41e+07. What is the difference between the highest and the lowest IMF credit(in current US$) of Lao PDR?
Provide a short and direct response. 1.77e+07. What is the difference between the highest and the lowest IMF credit(in current US$) of Vanuatu?
Your answer should be very brief. 5.26e+06. 